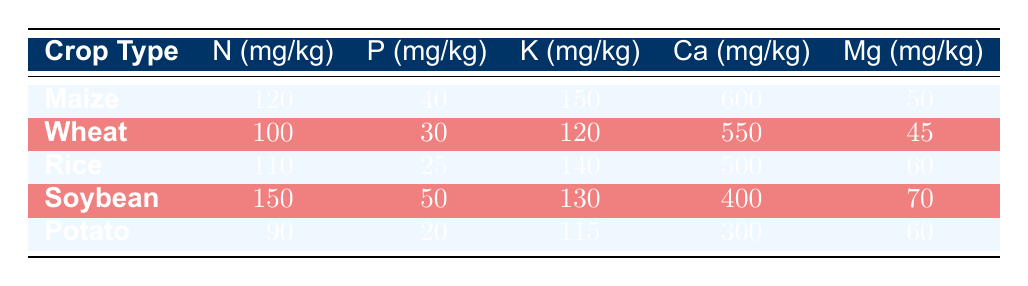What is the nitrogen level for Soybean? The table lists Soybean with a nitrogen level of 150 mg/kg.
Answer: 150 mg/kg Which crop has the highest potassium level? By looking at the potassium levels, Maize has 150 mg/kg, which is higher than the other crops: Wheat (120), Rice (140), Soybean (130), and Potato (115).
Answer: Maize Is the phosphorus level for Potato greater than 25 mg/kg? The phosphorus level for Potato is 20 mg/kg, which is less than 25 mg/kg, so the statement is false.
Answer: No What is the average calcium level across all crops? The calcium levels are 600 (Maize), 550 (Wheat), 500 (Rice), 400 (Soybean), and 300 (Potato). Summing these gives 600 + 550 + 500 + 400 + 300 = 2350 mg/kg. There are 5 crops, so the average is 2350/5 = 470 mg/kg.
Answer: 470 mg/kg Which crop has the lowest magnesium level? By comparing all magnesium levels, Wheat has 45 mg/kg, which is less than the other crops: Maize (50), Rice (60), Soybean (70), and Potato (60).
Answer: Wheat 